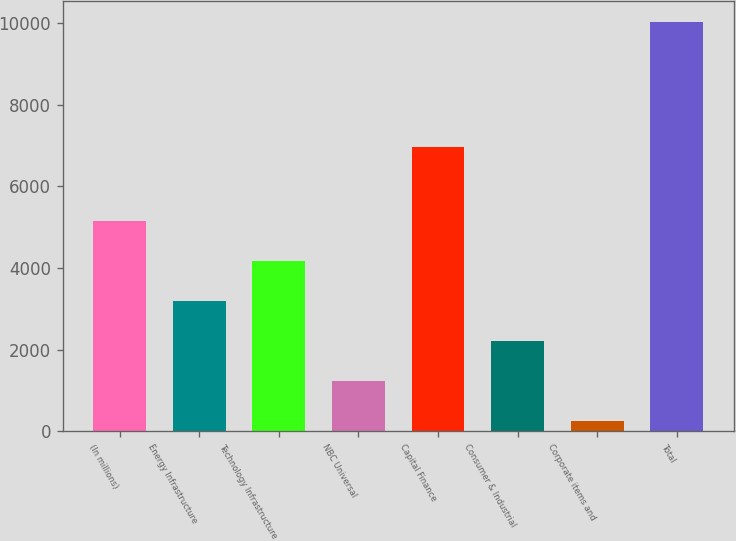Convert chart to OTSL. <chart><loc_0><loc_0><loc_500><loc_500><bar_chart><fcel>(In millions)<fcel>Energy Infrastructure<fcel>Technology Infrastructure<fcel>NBC Universal<fcel>Capital Finance<fcel>Consumer & Industrial<fcel>Corporate items and<fcel>Total<nl><fcel>5147<fcel>3193<fcel>4170<fcel>1239<fcel>6971<fcel>2216<fcel>262<fcel>10032<nl></chart> 